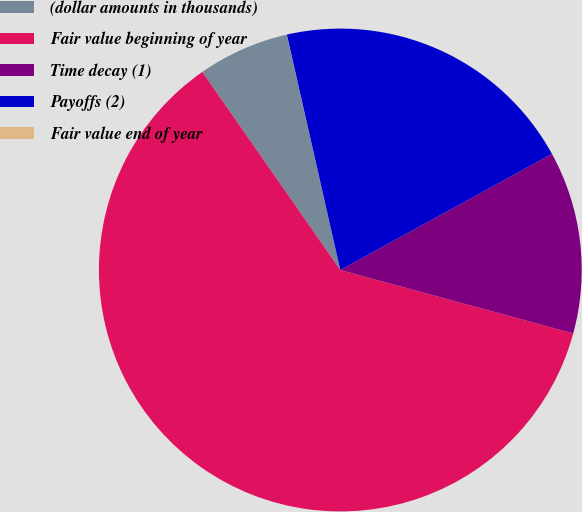Convert chart. <chart><loc_0><loc_0><loc_500><loc_500><pie_chart><fcel>(dollar amounts in thousands)<fcel>Fair value beginning of year<fcel>Time decay (1)<fcel>Payoffs (2)<fcel>Fair value end of year<nl><fcel>6.12%<fcel>61.09%<fcel>12.22%<fcel>20.57%<fcel>0.01%<nl></chart> 